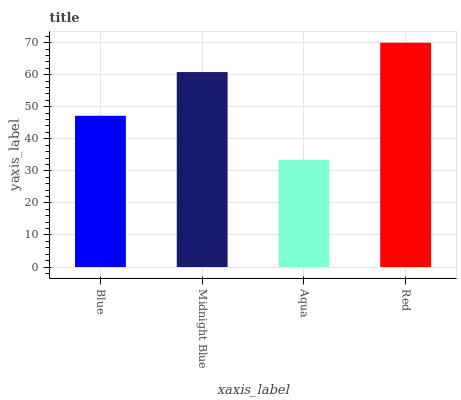Is Aqua the minimum?
Answer yes or no. Yes. Is Red the maximum?
Answer yes or no. Yes. Is Midnight Blue the minimum?
Answer yes or no. No. Is Midnight Blue the maximum?
Answer yes or no. No. Is Midnight Blue greater than Blue?
Answer yes or no. Yes. Is Blue less than Midnight Blue?
Answer yes or no. Yes. Is Blue greater than Midnight Blue?
Answer yes or no. No. Is Midnight Blue less than Blue?
Answer yes or no. No. Is Midnight Blue the high median?
Answer yes or no. Yes. Is Blue the low median?
Answer yes or no. Yes. Is Aqua the high median?
Answer yes or no. No. Is Red the low median?
Answer yes or no. No. 